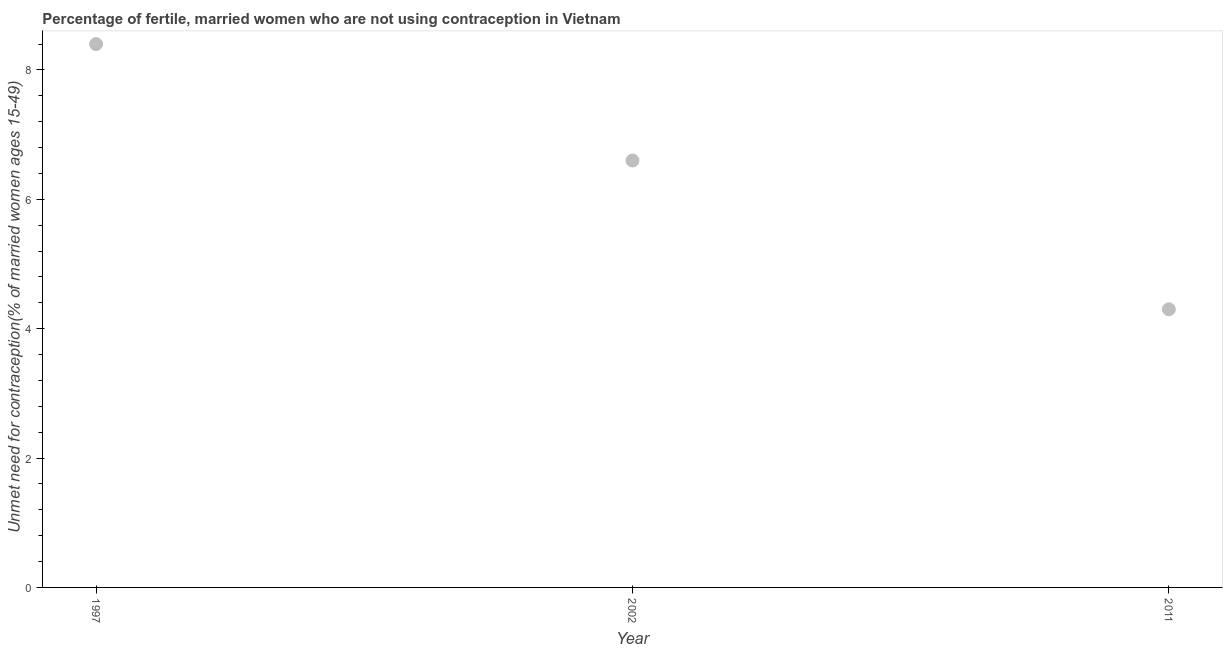What is the number of married women who are not using contraception in 1997?
Provide a short and direct response. 8.4. Across all years, what is the maximum number of married women who are not using contraception?
Offer a very short reply. 8.4. In which year was the number of married women who are not using contraception maximum?
Keep it short and to the point. 1997. What is the sum of the number of married women who are not using contraception?
Your answer should be very brief. 19.3. What is the difference between the number of married women who are not using contraception in 2002 and 2011?
Keep it short and to the point. 2.3. What is the average number of married women who are not using contraception per year?
Make the answer very short. 6.43. What is the median number of married women who are not using contraception?
Provide a succinct answer. 6.6. In how many years, is the number of married women who are not using contraception greater than 7.6 %?
Ensure brevity in your answer.  1. What is the ratio of the number of married women who are not using contraception in 1997 to that in 2011?
Make the answer very short. 1.95. Is the number of married women who are not using contraception in 1997 less than that in 2002?
Keep it short and to the point. No. Is the difference between the number of married women who are not using contraception in 1997 and 2002 greater than the difference between any two years?
Ensure brevity in your answer.  No. What is the difference between the highest and the second highest number of married women who are not using contraception?
Offer a very short reply. 1.8. Is the sum of the number of married women who are not using contraception in 1997 and 2002 greater than the maximum number of married women who are not using contraception across all years?
Your response must be concise. Yes. What is the difference between the highest and the lowest number of married women who are not using contraception?
Offer a terse response. 4.1. Does the number of married women who are not using contraception monotonically increase over the years?
Offer a terse response. No. Are the values on the major ticks of Y-axis written in scientific E-notation?
Make the answer very short. No. What is the title of the graph?
Your answer should be compact. Percentage of fertile, married women who are not using contraception in Vietnam. What is the label or title of the X-axis?
Offer a very short reply. Year. What is the label or title of the Y-axis?
Offer a terse response.  Unmet need for contraception(% of married women ages 15-49). What is the  Unmet need for contraception(% of married women ages 15-49) in 2002?
Your answer should be very brief. 6.6. What is the  Unmet need for contraception(% of married women ages 15-49) in 2011?
Provide a short and direct response. 4.3. What is the difference between the  Unmet need for contraception(% of married women ages 15-49) in 1997 and 2002?
Provide a short and direct response. 1.8. What is the difference between the  Unmet need for contraception(% of married women ages 15-49) in 1997 and 2011?
Provide a succinct answer. 4.1. What is the ratio of the  Unmet need for contraception(% of married women ages 15-49) in 1997 to that in 2002?
Make the answer very short. 1.27. What is the ratio of the  Unmet need for contraception(% of married women ages 15-49) in 1997 to that in 2011?
Your answer should be very brief. 1.95. What is the ratio of the  Unmet need for contraception(% of married women ages 15-49) in 2002 to that in 2011?
Your answer should be compact. 1.53. 